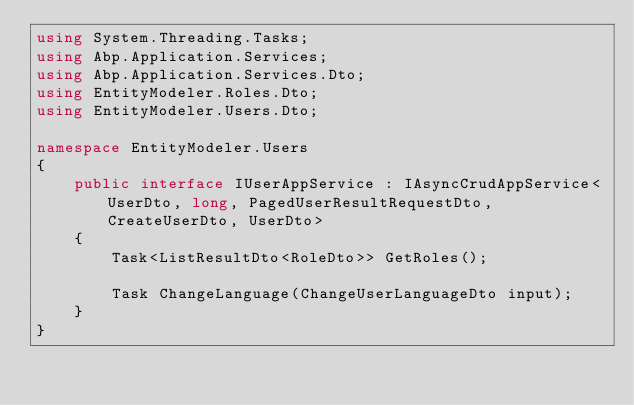Convert code to text. <code><loc_0><loc_0><loc_500><loc_500><_C#_>using System.Threading.Tasks;
using Abp.Application.Services;
using Abp.Application.Services.Dto;
using EntityModeler.Roles.Dto;
using EntityModeler.Users.Dto;

namespace EntityModeler.Users
{
    public interface IUserAppService : IAsyncCrudAppService<UserDto, long, PagedUserResultRequestDto, CreateUserDto, UserDto>
    {
        Task<ListResultDto<RoleDto>> GetRoles();

        Task ChangeLanguage(ChangeUserLanguageDto input);
    }
}
</code> 